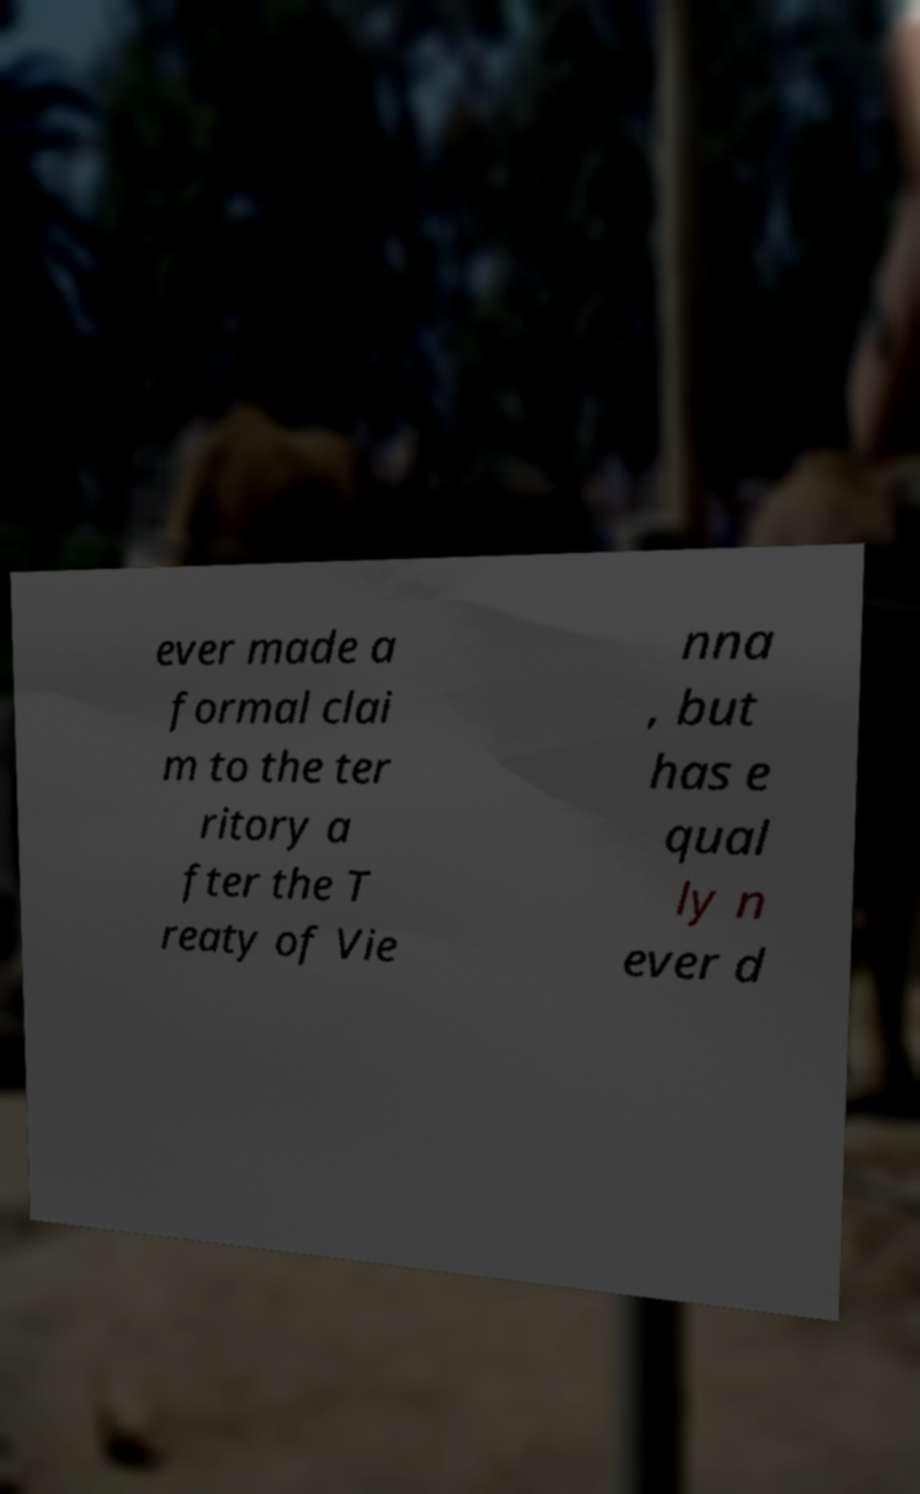There's text embedded in this image that I need extracted. Can you transcribe it verbatim? ever made a formal clai m to the ter ritory a fter the T reaty of Vie nna , but has e qual ly n ever d 